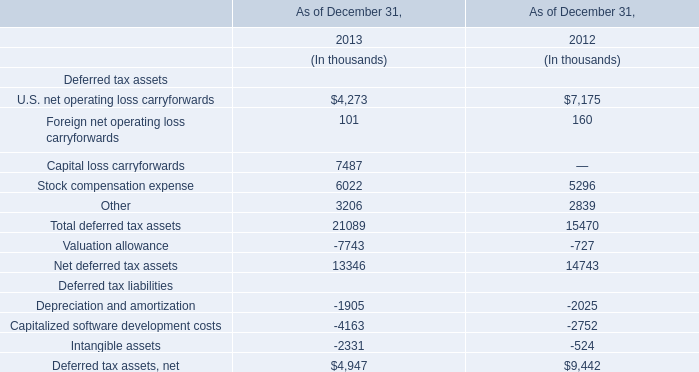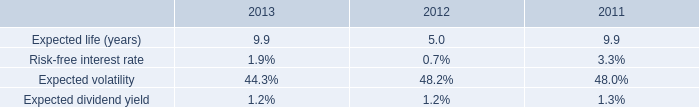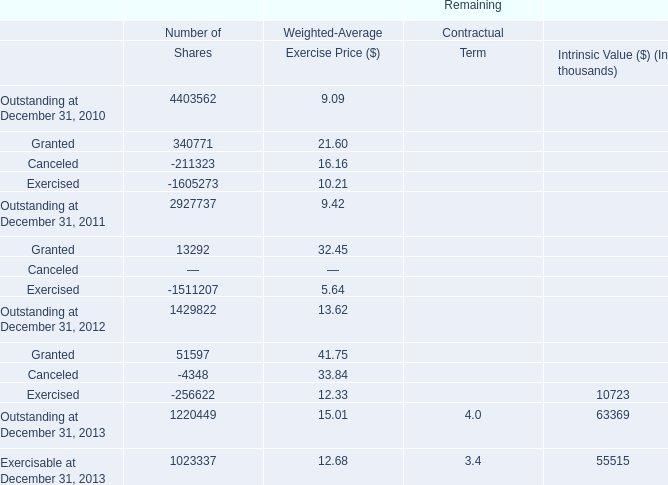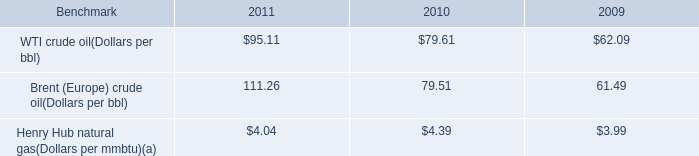What is the ratio of Granted of Number of Shares in Table 2 to the Net deferred tax assets in Table 0 in 2012? 
Computations: (51597 / 14743)
Answer: 3.49976. 